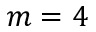Convert formula to latex. <formula><loc_0><loc_0><loc_500><loc_500>m = 4</formula> 